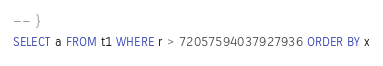Convert code to text. <code><loc_0><loc_0><loc_500><loc_500><_SQL_>-- }
SELECT a FROM t1 WHERE r > 72057594037927936 ORDER BY x</code> 